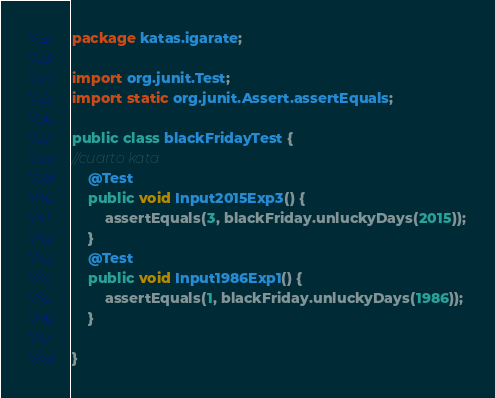<code> <loc_0><loc_0><loc_500><loc_500><_Java_>package katas.igarate;

import org.junit.Test;
import static org.junit.Assert.assertEquals;

public class blackFridayTest {
//cuarto kata
    @Test
    public void Input2015Exp3() {
        assertEquals(3, blackFriday.unluckyDays(2015));
    }
    @Test
    public void Input1986Exp1() {
        assertEquals(1, blackFriday.unluckyDays(1986));
    }

}
</code> 